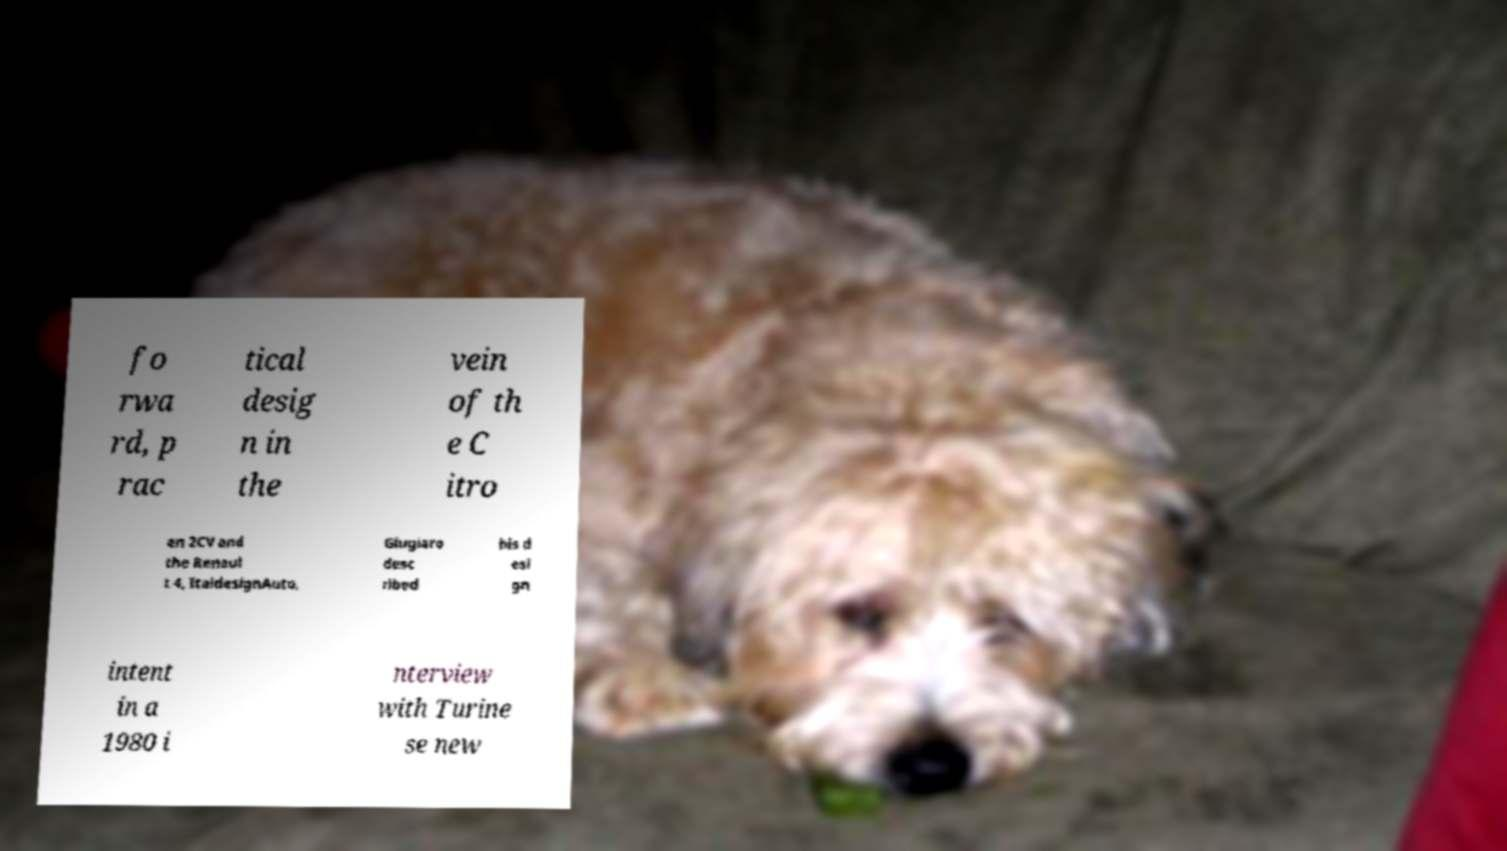Could you extract and type out the text from this image? fo rwa rd, p rac tical desig n in the vein of th e C itro en 2CV and the Renaul t 4, ItaldesignAuto, Giugiaro desc ribed his d esi gn intent in a 1980 i nterview with Turine se new 